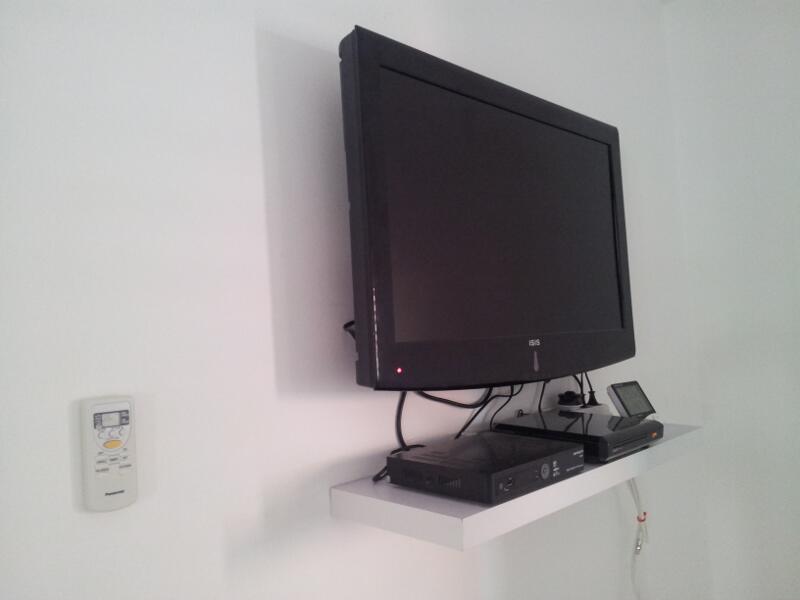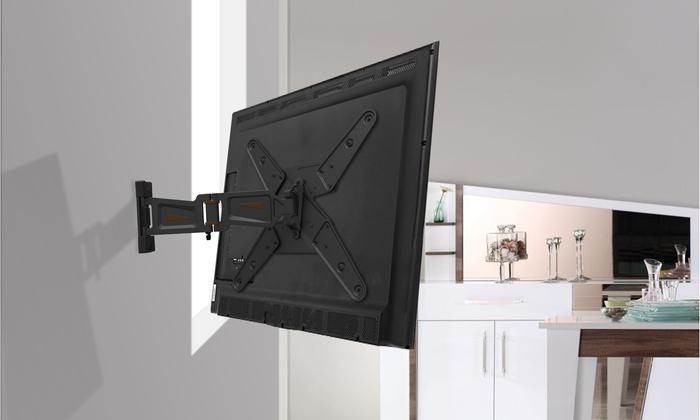The first image is the image on the left, the second image is the image on the right. Assess this claim about the two images: "In the left image a television is attached to the wall.". Correct or not? Answer yes or no. Yes. The first image is the image on the left, the second image is the image on the right. For the images shown, is this caption "The right image shows a side-view of a TV on a pivoting wall-mounted arm, and the left image shows a TV screen above a narrow shelf." true? Answer yes or no. Yes. 